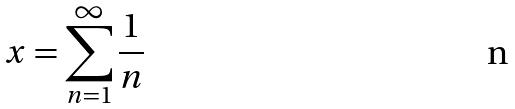<formula> <loc_0><loc_0><loc_500><loc_500>x = \sum _ { n = 1 } ^ { \infty } \frac { 1 } { n }</formula> 